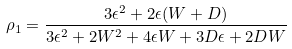Convert formula to latex. <formula><loc_0><loc_0><loc_500><loc_500>\rho _ { 1 } = \frac { 3 \epsilon ^ { 2 } + 2 \epsilon ( W + D ) } { 3 \epsilon ^ { 2 } + 2 W ^ { 2 } + 4 \epsilon W + 3 D \epsilon + 2 D W }</formula> 